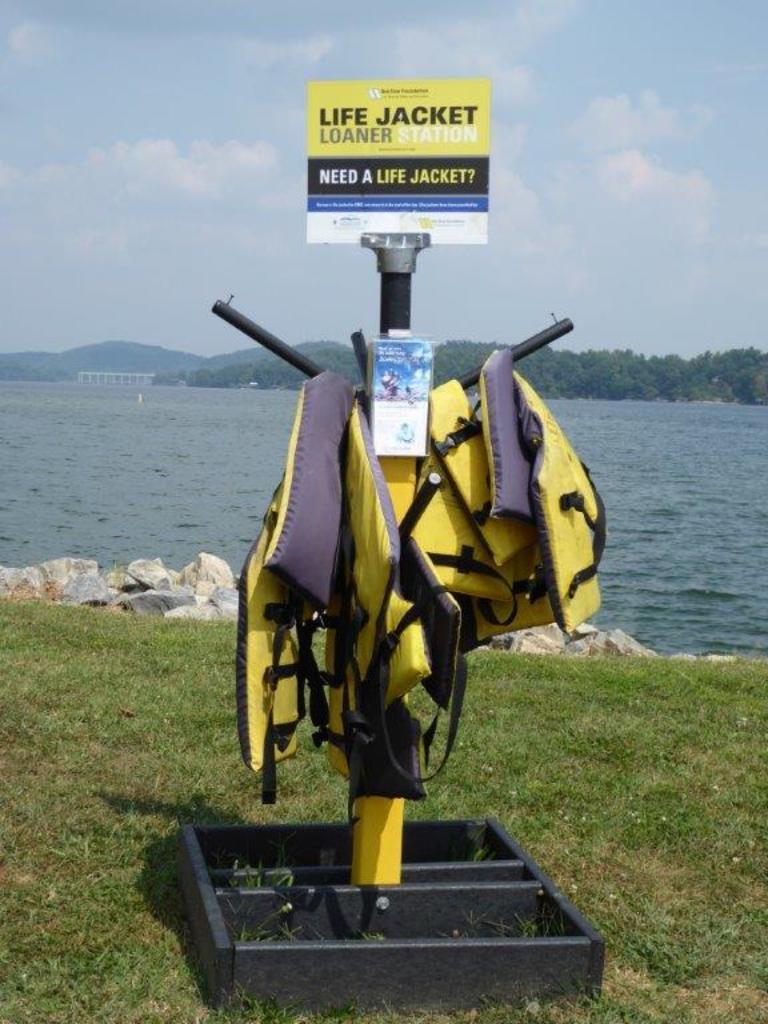Please provide a concise description of this image. In this picture we can see a stand with yellow colored jackets. And there is a board attached to it mentioned life jacket loaner station. This is grass and these are the stones. Even we can see some water here. And on the background there are trees. This is sky with clouds. 